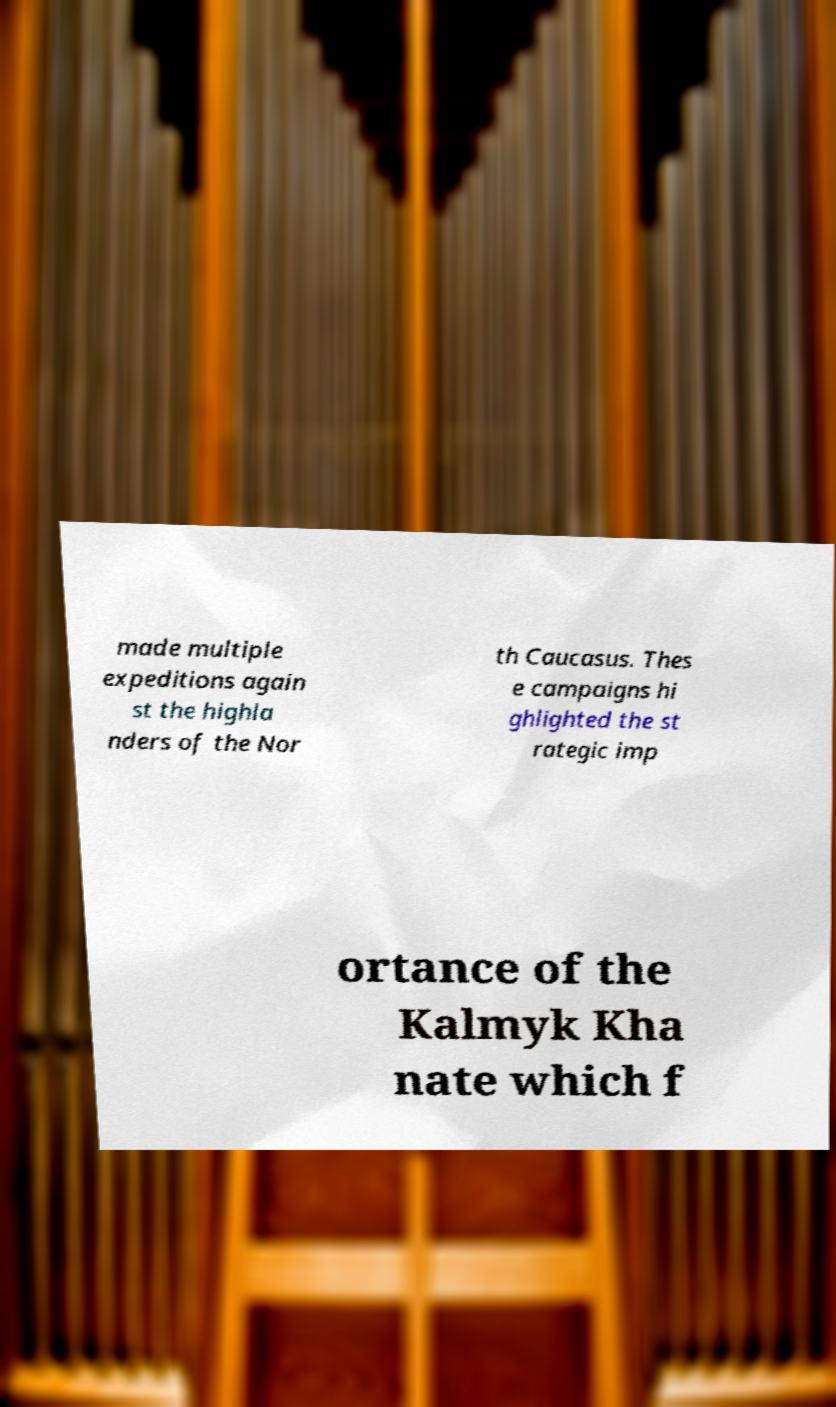Can you read and provide the text displayed in the image?This photo seems to have some interesting text. Can you extract and type it out for me? made multiple expeditions again st the highla nders of the Nor th Caucasus. Thes e campaigns hi ghlighted the st rategic imp ortance of the Kalmyk Kha nate which f 